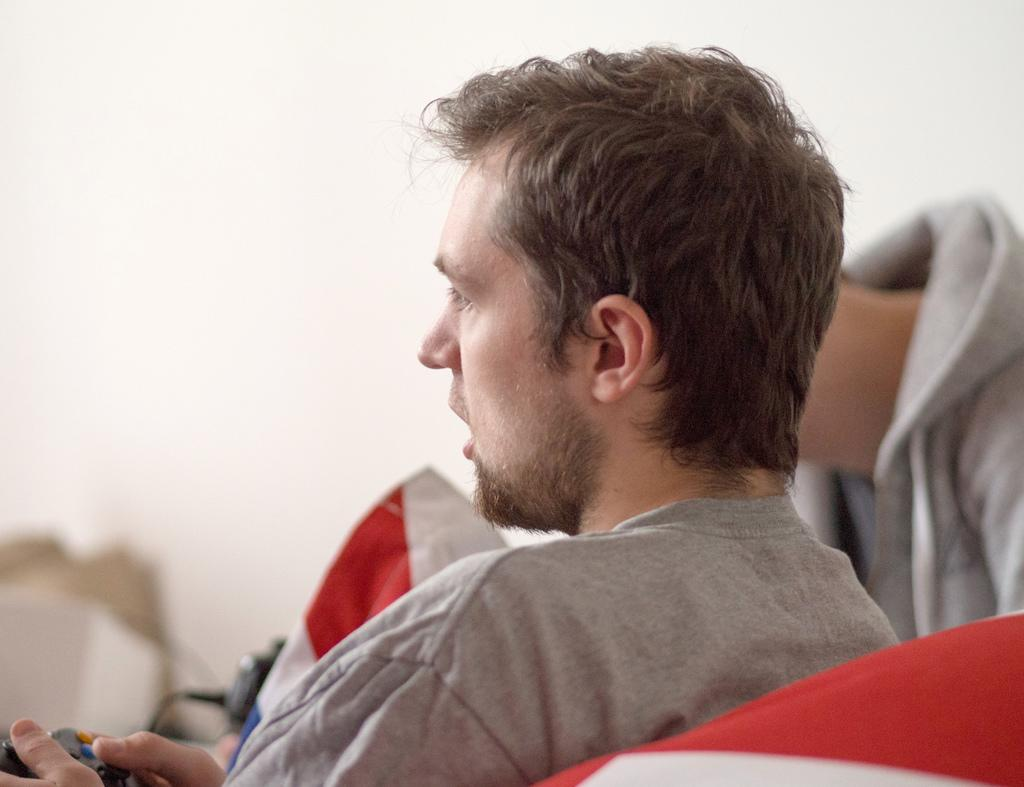What can be seen in the image? There is a person in the image. What is the person holding? The person is holding an object. Can you describe any other elements in the image? There is a cloth visible in the image, and there are other objects present as well. What is visible in the background of the image? There is a wall in the background of the image. What month is the person thinking about in the image? There is no indication of the person thinking about a specific month in the image. Can you tell me the age of the person's grandfather in the image? There is no mention of a grandfather or any family members in the image. 